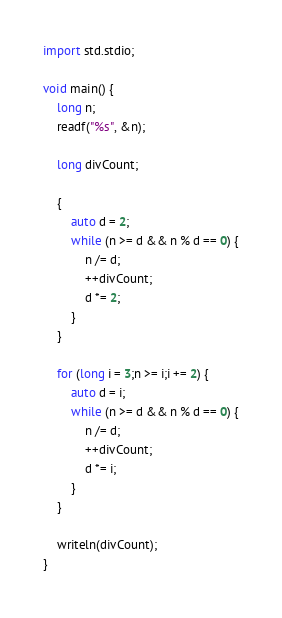Convert code to text. <code><loc_0><loc_0><loc_500><loc_500><_D_>import std.stdio;

void main() {
	long n;
	readf("%s", &n);

	long divCount;

	{
		auto d = 2;
		while (n >= d && n % d == 0) {
			n /= d;
			++divCount;
			d *= 2;
		}
	}
	
	for (long i = 3;n >= i;i += 2) {
		auto d = i;
		while (n >= d && n % d == 0) {
			n /= d;
			++divCount;
			d *= i;
		}
	}

	writeln(divCount);
}
</code> 